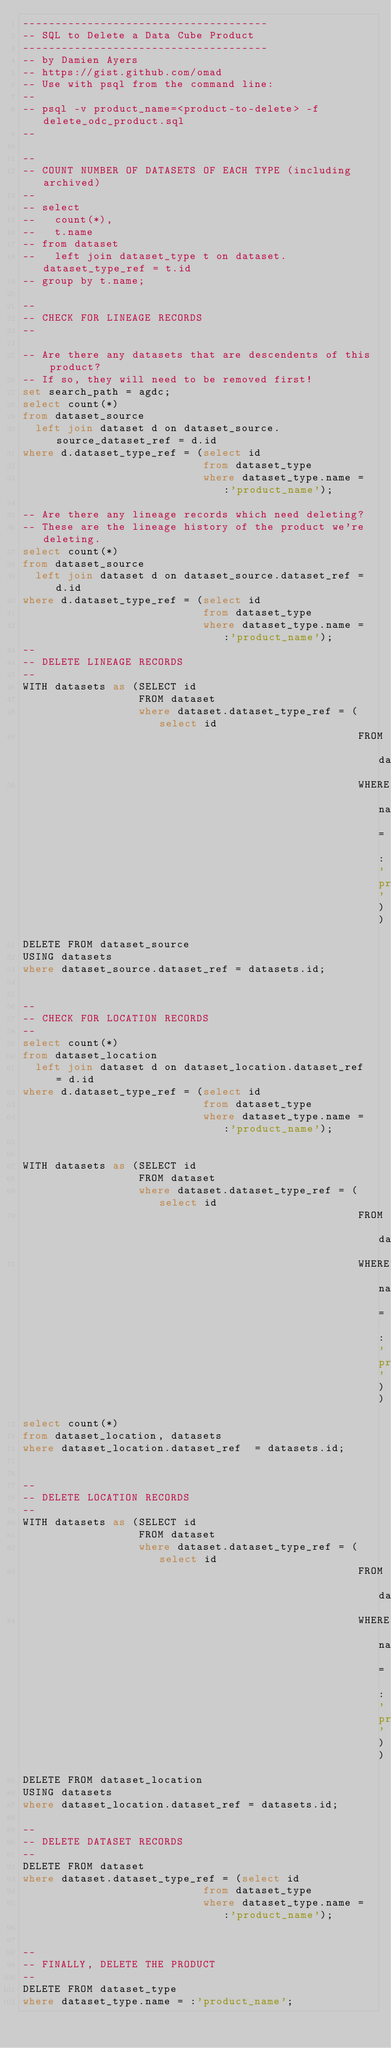<code> <loc_0><loc_0><loc_500><loc_500><_SQL_>--------------------------------------
-- SQL to Delete a Data Cube Product
--------------------------------------
-- by Damien Ayers
-- https://gist.github.com/omad
-- Use with psql from the command line:
--
-- psql -v product_name=<product-to-delete> -f delete_odc_product.sql
--

--
-- COUNT NUMBER OF DATASETS OF EACH TYPE (including archived)
--
-- select
--   count(*),
--   t.name
-- from dataset
--   left join dataset_type t on dataset.dataset_type_ref = t.id
-- group by t.name;

--
-- CHECK FOR LINEAGE RECORDS
--

-- Are there any datasets that are descendents of this product?
-- If so, they will need to be removed first!
set search_path = agdc;
select count(*)
from dataset_source
  left join dataset d on dataset_source.source_dataset_ref = d.id
where d.dataset_type_ref = (select id
                            from dataset_type
                            where dataset_type.name = :'product_name');

-- Are there any lineage records which need deleting?
-- These are the lineage history of the product we're deleting.
select count(*)
from dataset_source
  left join dataset d on dataset_source.dataset_ref = d.id
where d.dataset_type_ref = (select id
                            from dataset_type
                            where dataset_type.name = :'product_name');
--
-- DELETE LINEAGE RECORDS
--
WITH datasets as (SELECT id
                  FROM dataset
                  where dataset.dataset_type_ref = (select id
                                                    FROM dataset_type
                                                    WHERE name = :'product_name'))
DELETE FROM dataset_source
USING datasets
where dataset_source.dataset_ref = datasets.id;


--
-- CHECK FOR LOCATION RECORDS
--
select count(*)
from dataset_location
  left join dataset d on dataset_location.dataset_ref = d.id
where d.dataset_type_ref = (select id
                            from dataset_type
                            where dataset_type.name = :'product_name');


WITH datasets as (SELECT id
                  FROM dataset
                  where dataset.dataset_type_ref = (select id
                                                    FROM dataset_type
                                                    WHERE name = :'product_name'))
select count(*)
from dataset_location, datasets
where dataset_location.dataset_ref  = datasets.id;


--
-- DELETE LOCATION RECORDS
--
WITH datasets as (SELECT id
                  FROM dataset
                  where dataset.dataset_type_ref = (select id
                                                    FROM dataset_type
                                                    WHERE name = :'product_name'))
DELETE FROM dataset_location
USING datasets
where dataset_location.dataset_ref = datasets.id;

--
-- DELETE DATASET RECORDS
--
DELETE FROM dataset
where dataset.dataset_type_ref = (select id
                            from dataset_type
                            where dataset_type.name = :'product_name');


--
-- FINALLY, DELETE THE PRODUCT
--
DELETE FROM dataset_type
where dataset_type.name = :'product_name';</code> 